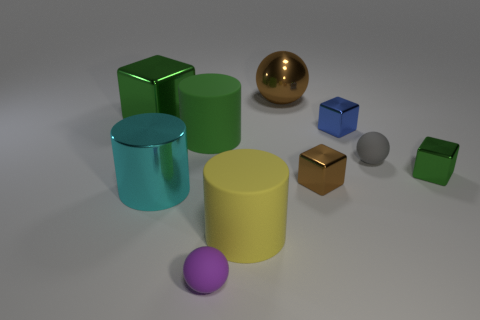If these objects were part of a game, what kind of game could it be? If these objects were part of a game, it could be a physics-based puzzle game where the goal is to arrange the objects to achieve balance or build structures. Alternatively, it could be an educational game for children, aimed at teaching shapes and colors or even basic principles of geometry and materials. 